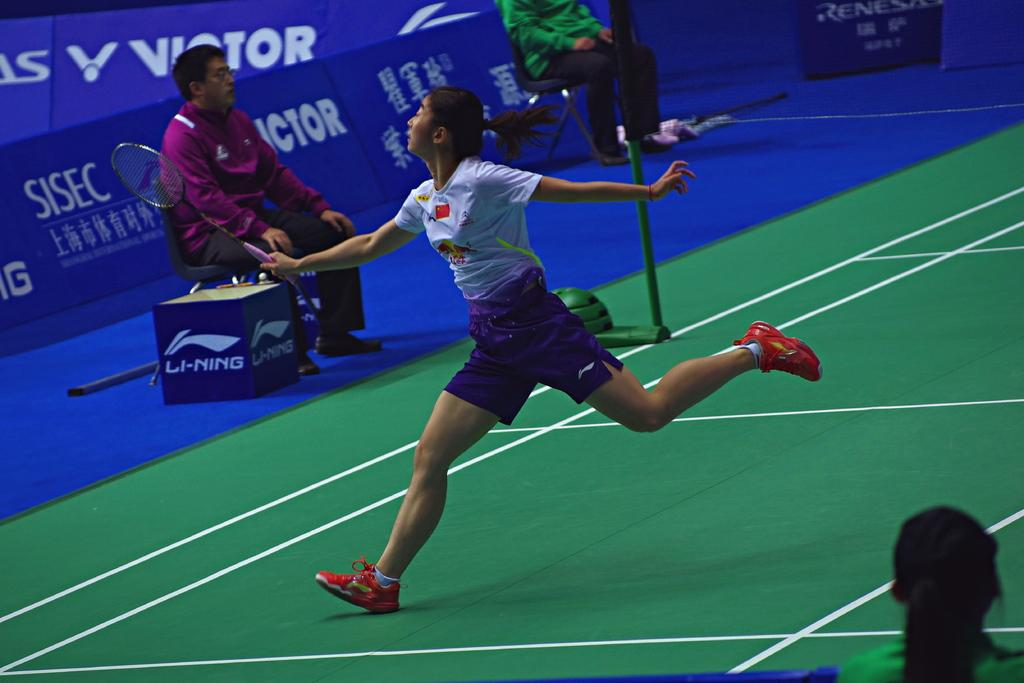How many people are present in the image? There are four people in the image. What are two of the people doing in the image? Two of the people are sitting on chairs. What object can be seen in the image besides the people? There is a box in the image. What action is being performed by one of the people in the image? A woman is running in the image. What type of mark can be seen on the furniture in the image? There is no furniture present in the image, so it is not possible to determine if there is a mark on any furniture. 